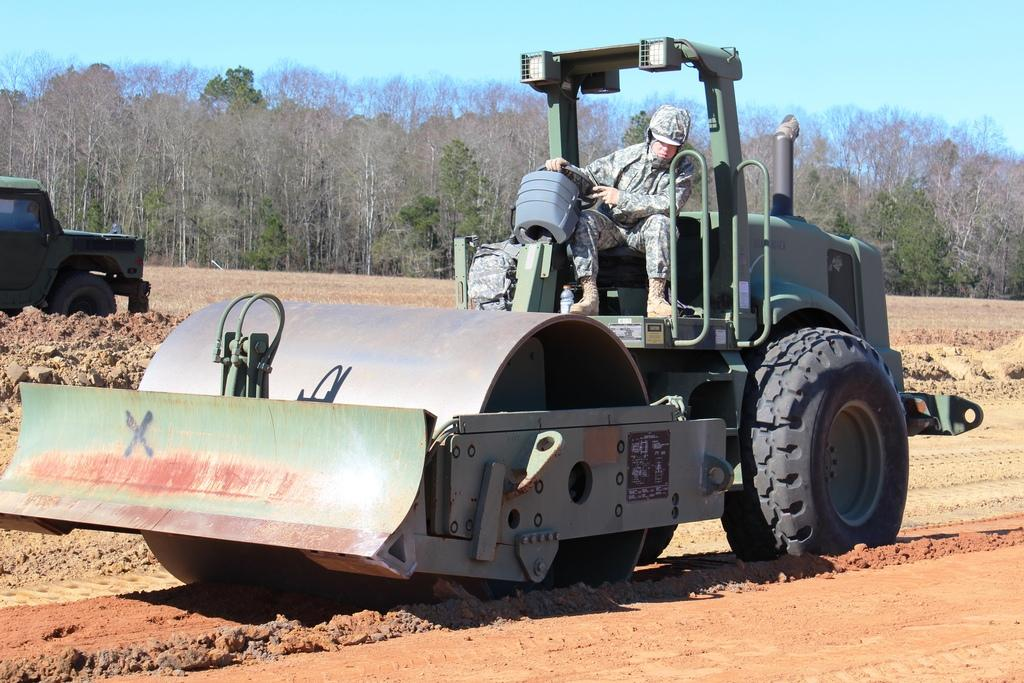What type of vehicle is in the image? There is a road roller in the image. Where is the road roller located? The road roller is on land. Who is operating the road roller? There is a person driving the road roller. What can be seen in the background of the image? There are trees and the sky visible in the background of the image. What type of account does the road roller have in the image? The road roller does not have an account in the image, as it is a vehicle and not a person or entity capable of having an account. 